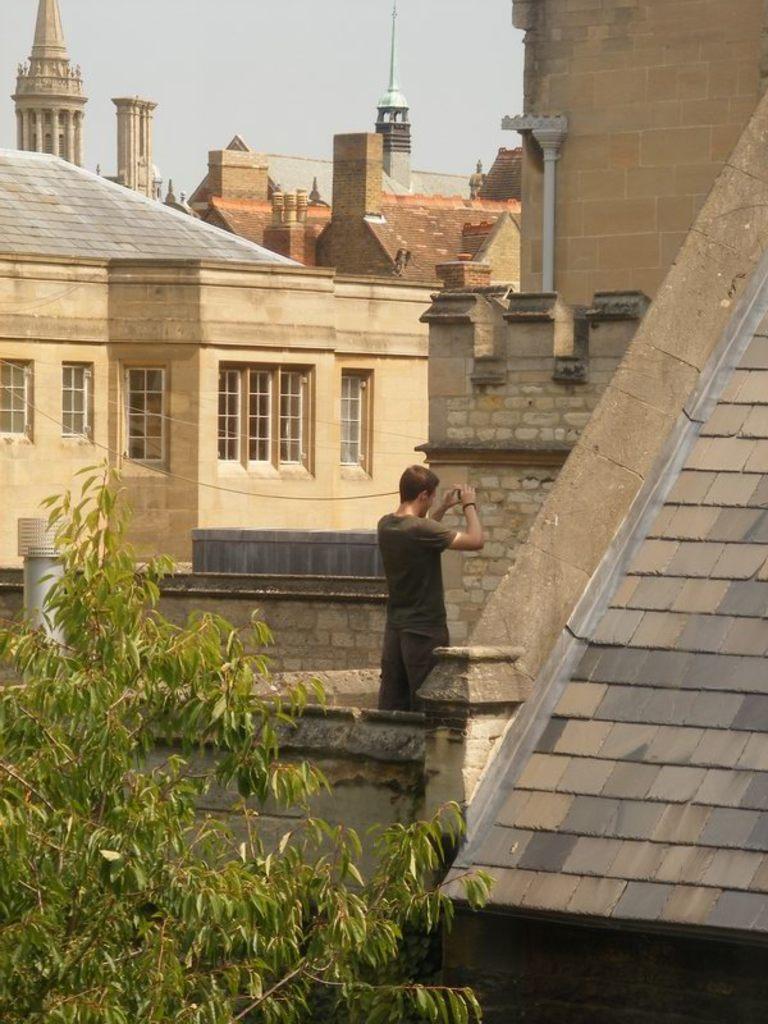How would you summarize this image in a sentence or two? In this picture, we can see a person, buildings with glass doors, tree and the sky. 